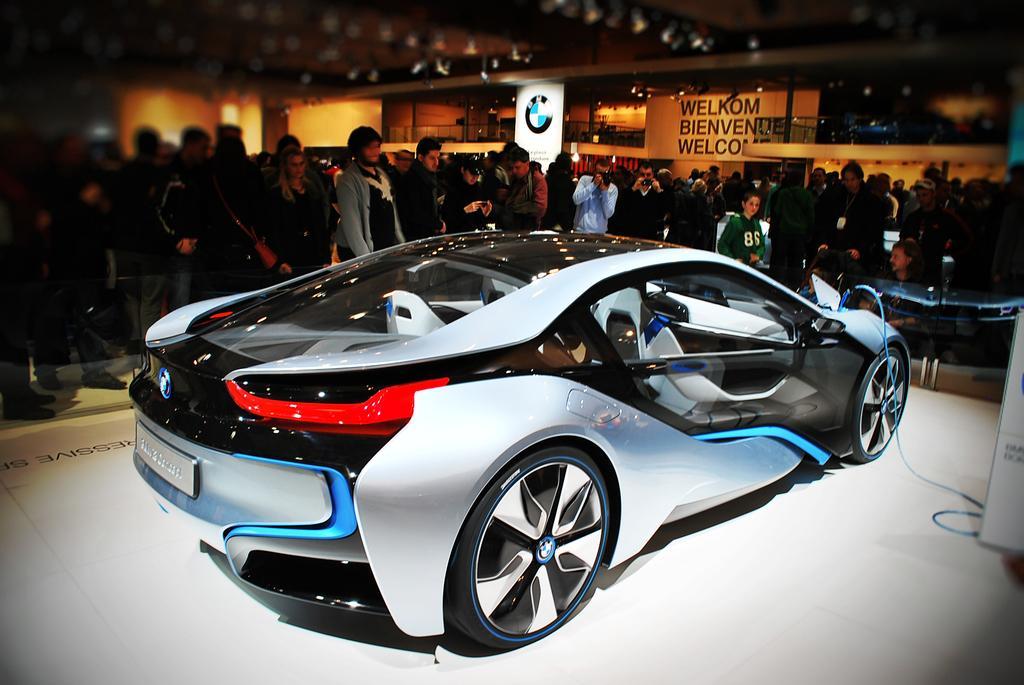Could you give a brief overview of what you see in this image? In this image in the center there is one car and in the background there are some people who are standing, and also there are some boards. On the top there is ceiling and some lights, at the bottom there is a floor. 